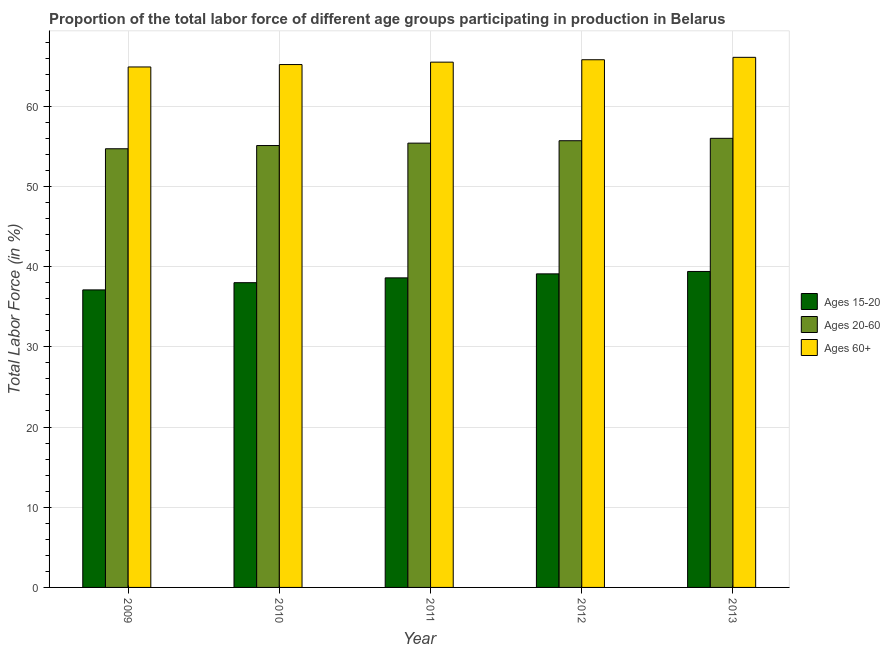How many groups of bars are there?
Offer a terse response. 5. Are the number of bars per tick equal to the number of legend labels?
Ensure brevity in your answer.  Yes. Are the number of bars on each tick of the X-axis equal?
Ensure brevity in your answer.  Yes. How many bars are there on the 4th tick from the left?
Provide a succinct answer. 3. How many bars are there on the 4th tick from the right?
Your answer should be compact. 3. In how many cases, is the number of bars for a given year not equal to the number of legend labels?
Make the answer very short. 0. What is the percentage of labor force above age 60 in 2010?
Ensure brevity in your answer.  65.2. Across all years, what is the maximum percentage of labor force within the age group 15-20?
Give a very brief answer. 39.4. Across all years, what is the minimum percentage of labor force within the age group 20-60?
Your answer should be compact. 54.7. In which year was the percentage of labor force within the age group 15-20 minimum?
Your answer should be very brief. 2009. What is the total percentage of labor force above age 60 in the graph?
Offer a terse response. 327.5. What is the difference between the percentage of labor force within the age group 15-20 in 2009 and that in 2013?
Your answer should be very brief. -2.3. What is the difference between the percentage of labor force within the age group 15-20 in 2011 and the percentage of labor force above age 60 in 2013?
Give a very brief answer. -0.8. What is the average percentage of labor force within the age group 20-60 per year?
Give a very brief answer. 55.38. In how many years, is the percentage of labor force above age 60 greater than 28 %?
Give a very brief answer. 5. What is the ratio of the percentage of labor force within the age group 15-20 in 2009 to that in 2010?
Give a very brief answer. 0.98. Is the difference between the percentage of labor force above age 60 in 2011 and 2012 greater than the difference between the percentage of labor force within the age group 20-60 in 2011 and 2012?
Give a very brief answer. No. What is the difference between the highest and the second highest percentage of labor force above age 60?
Your answer should be compact. 0.3. What is the difference between the highest and the lowest percentage of labor force above age 60?
Make the answer very short. 1.2. In how many years, is the percentage of labor force within the age group 20-60 greater than the average percentage of labor force within the age group 20-60 taken over all years?
Ensure brevity in your answer.  3. Is the sum of the percentage of labor force within the age group 15-20 in 2011 and 2013 greater than the maximum percentage of labor force within the age group 20-60 across all years?
Your response must be concise. Yes. What does the 3rd bar from the left in 2011 represents?
Give a very brief answer. Ages 60+. What does the 2nd bar from the right in 2010 represents?
Your answer should be very brief. Ages 20-60. How many bars are there?
Provide a short and direct response. 15. Are all the bars in the graph horizontal?
Offer a terse response. No. How are the legend labels stacked?
Offer a very short reply. Vertical. What is the title of the graph?
Your answer should be very brief. Proportion of the total labor force of different age groups participating in production in Belarus. What is the label or title of the X-axis?
Your answer should be very brief. Year. What is the label or title of the Y-axis?
Give a very brief answer. Total Labor Force (in %). What is the Total Labor Force (in %) in Ages 15-20 in 2009?
Offer a very short reply. 37.1. What is the Total Labor Force (in %) in Ages 20-60 in 2009?
Make the answer very short. 54.7. What is the Total Labor Force (in %) in Ages 60+ in 2009?
Your answer should be very brief. 64.9. What is the Total Labor Force (in %) in Ages 15-20 in 2010?
Ensure brevity in your answer.  38. What is the Total Labor Force (in %) of Ages 20-60 in 2010?
Your answer should be very brief. 55.1. What is the Total Labor Force (in %) in Ages 60+ in 2010?
Give a very brief answer. 65.2. What is the Total Labor Force (in %) of Ages 15-20 in 2011?
Your answer should be very brief. 38.6. What is the Total Labor Force (in %) of Ages 20-60 in 2011?
Your answer should be compact. 55.4. What is the Total Labor Force (in %) in Ages 60+ in 2011?
Offer a terse response. 65.5. What is the Total Labor Force (in %) in Ages 15-20 in 2012?
Offer a terse response. 39.1. What is the Total Labor Force (in %) in Ages 20-60 in 2012?
Provide a succinct answer. 55.7. What is the Total Labor Force (in %) in Ages 60+ in 2012?
Offer a terse response. 65.8. What is the Total Labor Force (in %) of Ages 15-20 in 2013?
Offer a terse response. 39.4. What is the Total Labor Force (in %) of Ages 20-60 in 2013?
Ensure brevity in your answer.  56. What is the Total Labor Force (in %) of Ages 60+ in 2013?
Offer a very short reply. 66.1. Across all years, what is the maximum Total Labor Force (in %) of Ages 15-20?
Make the answer very short. 39.4. Across all years, what is the maximum Total Labor Force (in %) of Ages 60+?
Provide a succinct answer. 66.1. Across all years, what is the minimum Total Labor Force (in %) of Ages 15-20?
Your answer should be compact. 37.1. Across all years, what is the minimum Total Labor Force (in %) in Ages 20-60?
Make the answer very short. 54.7. Across all years, what is the minimum Total Labor Force (in %) of Ages 60+?
Ensure brevity in your answer.  64.9. What is the total Total Labor Force (in %) of Ages 15-20 in the graph?
Keep it short and to the point. 192.2. What is the total Total Labor Force (in %) in Ages 20-60 in the graph?
Provide a succinct answer. 276.9. What is the total Total Labor Force (in %) in Ages 60+ in the graph?
Provide a succinct answer. 327.5. What is the difference between the Total Labor Force (in %) in Ages 15-20 in 2009 and that in 2010?
Provide a short and direct response. -0.9. What is the difference between the Total Labor Force (in %) in Ages 20-60 in 2009 and that in 2010?
Your response must be concise. -0.4. What is the difference between the Total Labor Force (in %) in Ages 60+ in 2009 and that in 2010?
Provide a short and direct response. -0.3. What is the difference between the Total Labor Force (in %) of Ages 15-20 in 2009 and that in 2011?
Give a very brief answer. -1.5. What is the difference between the Total Labor Force (in %) of Ages 20-60 in 2009 and that in 2011?
Ensure brevity in your answer.  -0.7. What is the difference between the Total Labor Force (in %) of Ages 20-60 in 2009 and that in 2012?
Give a very brief answer. -1. What is the difference between the Total Labor Force (in %) of Ages 20-60 in 2009 and that in 2013?
Provide a succinct answer. -1.3. What is the difference between the Total Labor Force (in %) in Ages 15-20 in 2010 and that in 2011?
Provide a succinct answer. -0.6. What is the difference between the Total Labor Force (in %) in Ages 60+ in 2010 and that in 2011?
Your response must be concise. -0.3. What is the difference between the Total Labor Force (in %) of Ages 15-20 in 2010 and that in 2012?
Offer a terse response. -1.1. What is the difference between the Total Labor Force (in %) in Ages 60+ in 2010 and that in 2012?
Offer a very short reply. -0.6. What is the difference between the Total Labor Force (in %) of Ages 60+ in 2010 and that in 2013?
Keep it short and to the point. -0.9. What is the difference between the Total Labor Force (in %) of Ages 20-60 in 2011 and that in 2012?
Your answer should be compact. -0.3. What is the difference between the Total Labor Force (in %) in Ages 60+ in 2011 and that in 2012?
Ensure brevity in your answer.  -0.3. What is the difference between the Total Labor Force (in %) of Ages 15-20 in 2011 and that in 2013?
Keep it short and to the point. -0.8. What is the difference between the Total Labor Force (in %) of Ages 15-20 in 2012 and that in 2013?
Ensure brevity in your answer.  -0.3. What is the difference between the Total Labor Force (in %) in Ages 20-60 in 2012 and that in 2013?
Your answer should be compact. -0.3. What is the difference between the Total Labor Force (in %) in Ages 60+ in 2012 and that in 2013?
Keep it short and to the point. -0.3. What is the difference between the Total Labor Force (in %) of Ages 15-20 in 2009 and the Total Labor Force (in %) of Ages 20-60 in 2010?
Provide a short and direct response. -18. What is the difference between the Total Labor Force (in %) in Ages 15-20 in 2009 and the Total Labor Force (in %) in Ages 60+ in 2010?
Keep it short and to the point. -28.1. What is the difference between the Total Labor Force (in %) of Ages 15-20 in 2009 and the Total Labor Force (in %) of Ages 20-60 in 2011?
Offer a very short reply. -18.3. What is the difference between the Total Labor Force (in %) in Ages 15-20 in 2009 and the Total Labor Force (in %) in Ages 60+ in 2011?
Provide a succinct answer. -28.4. What is the difference between the Total Labor Force (in %) in Ages 15-20 in 2009 and the Total Labor Force (in %) in Ages 20-60 in 2012?
Provide a succinct answer. -18.6. What is the difference between the Total Labor Force (in %) in Ages 15-20 in 2009 and the Total Labor Force (in %) in Ages 60+ in 2012?
Provide a short and direct response. -28.7. What is the difference between the Total Labor Force (in %) of Ages 15-20 in 2009 and the Total Labor Force (in %) of Ages 20-60 in 2013?
Provide a succinct answer. -18.9. What is the difference between the Total Labor Force (in %) of Ages 20-60 in 2009 and the Total Labor Force (in %) of Ages 60+ in 2013?
Your answer should be very brief. -11.4. What is the difference between the Total Labor Force (in %) of Ages 15-20 in 2010 and the Total Labor Force (in %) of Ages 20-60 in 2011?
Your answer should be very brief. -17.4. What is the difference between the Total Labor Force (in %) of Ages 15-20 in 2010 and the Total Labor Force (in %) of Ages 60+ in 2011?
Your response must be concise. -27.5. What is the difference between the Total Labor Force (in %) of Ages 20-60 in 2010 and the Total Labor Force (in %) of Ages 60+ in 2011?
Make the answer very short. -10.4. What is the difference between the Total Labor Force (in %) of Ages 15-20 in 2010 and the Total Labor Force (in %) of Ages 20-60 in 2012?
Ensure brevity in your answer.  -17.7. What is the difference between the Total Labor Force (in %) in Ages 15-20 in 2010 and the Total Labor Force (in %) in Ages 60+ in 2012?
Ensure brevity in your answer.  -27.8. What is the difference between the Total Labor Force (in %) of Ages 20-60 in 2010 and the Total Labor Force (in %) of Ages 60+ in 2012?
Give a very brief answer. -10.7. What is the difference between the Total Labor Force (in %) in Ages 15-20 in 2010 and the Total Labor Force (in %) in Ages 20-60 in 2013?
Offer a very short reply. -18. What is the difference between the Total Labor Force (in %) in Ages 15-20 in 2010 and the Total Labor Force (in %) in Ages 60+ in 2013?
Offer a very short reply. -28.1. What is the difference between the Total Labor Force (in %) in Ages 15-20 in 2011 and the Total Labor Force (in %) in Ages 20-60 in 2012?
Your answer should be very brief. -17.1. What is the difference between the Total Labor Force (in %) in Ages 15-20 in 2011 and the Total Labor Force (in %) in Ages 60+ in 2012?
Keep it short and to the point. -27.2. What is the difference between the Total Labor Force (in %) in Ages 15-20 in 2011 and the Total Labor Force (in %) in Ages 20-60 in 2013?
Give a very brief answer. -17.4. What is the difference between the Total Labor Force (in %) of Ages 15-20 in 2011 and the Total Labor Force (in %) of Ages 60+ in 2013?
Ensure brevity in your answer.  -27.5. What is the difference between the Total Labor Force (in %) of Ages 20-60 in 2011 and the Total Labor Force (in %) of Ages 60+ in 2013?
Offer a very short reply. -10.7. What is the difference between the Total Labor Force (in %) of Ages 15-20 in 2012 and the Total Labor Force (in %) of Ages 20-60 in 2013?
Provide a short and direct response. -16.9. What is the difference between the Total Labor Force (in %) of Ages 15-20 in 2012 and the Total Labor Force (in %) of Ages 60+ in 2013?
Ensure brevity in your answer.  -27. What is the difference between the Total Labor Force (in %) of Ages 20-60 in 2012 and the Total Labor Force (in %) of Ages 60+ in 2013?
Your response must be concise. -10.4. What is the average Total Labor Force (in %) of Ages 15-20 per year?
Your answer should be very brief. 38.44. What is the average Total Labor Force (in %) in Ages 20-60 per year?
Provide a succinct answer. 55.38. What is the average Total Labor Force (in %) of Ages 60+ per year?
Provide a succinct answer. 65.5. In the year 2009, what is the difference between the Total Labor Force (in %) of Ages 15-20 and Total Labor Force (in %) of Ages 20-60?
Provide a succinct answer. -17.6. In the year 2009, what is the difference between the Total Labor Force (in %) in Ages 15-20 and Total Labor Force (in %) in Ages 60+?
Provide a short and direct response. -27.8. In the year 2010, what is the difference between the Total Labor Force (in %) in Ages 15-20 and Total Labor Force (in %) in Ages 20-60?
Keep it short and to the point. -17.1. In the year 2010, what is the difference between the Total Labor Force (in %) of Ages 15-20 and Total Labor Force (in %) of Ages 60+?
Your answer should be very brief. -27.2. In the year 2010, what is the difference between the Total Labor Force (in %) of Ages 20-60 and Total Labor Force (in %) of Ages 60+?
Make the answer very short. -10.1. In the year 2011, what is the difference between the Total Labor Force (in %) in Ages 15-20 and Total Labor Force (in %) in Ages 20-60?
Your response must be concise. -16.8. In the year 2011, what is the difference between the Total Labor Force (in %) of Ages 15-20 and Total Labor Force (in %) of Ages 60+?
Your response must be concise. -26.9. In the year 2012, what is the difference between the Total Labor Force (in %) in Ages 15-20 and Total Labor Force (in %) in Ages 20-60?
Keep it short and to the point. -16.6. In the year 2012, what is the difference between the Total Labor Force (in %) in Ages 15-20 and Total Labor Force (in %) in Ages 60+?
Keep it short and to the point. -26.7. In the year 2012, what is the difference between the Total Labor Force (in %) in Ages 20-60 and Total Labor Force (in %) in Ages 60+?
Offer a terse response. -10.1. In the year 2013, what is the difference between the Total Labor Force (in %) in Ages 15-20 and Total Labor Force (in %) in Ages 20-60?
Your answer should be very brief. -16.6. In the year 2013, what is the difference between the Total Labor Force (in %) of Ages 15-20 and Total Labor Force (in %) of Ages 60+?
Provide a short and direct response. -26.7. In the year 2013, what is the difference between the Total Labor Force (in %) in Ages 20-60 and Total Labor Force (in %) in Ages 60+?
Offer a very short reply. -10.1. What is the ratio of the Total Labor Force (in %) of Ages 15-20 in 2009 to that in 2010?
Offer a very short reply. 0.98. What is the ratio of the Total Labor Force (in %) in Ages 20-60 in 2009 to that in 2010?
Your response must be concise. 0.99. What is the ratio of the Total Labor Force (in %) of Ages 15-20 in 2009 to that in 2011?
Your answer should be very brief. 0.96. What is the ratio of the Total Labor Force (in %) of Ages 20-60 in 2009 to that in 2011?
Provide a succinct answer. 0.99. What is the ratio of the Total Labor Force (in %) in Ages 60+ in 2009 to that in 2011?
Provide a succinct answer. 0.99. What is the ratio of the Total Labor Force (in %) in Ages 15-20 in 2009 to that in 2012?
Make the answer very short. 0.95. What is the ratio of the Total Labor Force (in %) in Ages 60+ in 2009 to that in 2012?
Ensure brevity in your answer.  0.99. What is the ratio of the Total Labor Force (in %) in Ages 15-20 in 2009 to that in 2013?
Offer a terse response. 0.94. What is the ratio of the Total Labor Force (in %) of Ages 20-60 in 2009 to that in 2013?
Offer a very short reply. 0.98. What is the ratio of the Total Labor Force (in %) of Ages 60+ in 2009 to that in 2013?
Keep it short and to the point. 0.98. What is the ratio of the Total Labor Force (in %) of Ages 15-20 in 2010 to that in 2011?
Offer a terse response. 0.98. What is the ratio of the Total Labor Force (in %) in Ages 20-60 in 2010 to that in 2011?
Provide a short and direct response. 0.99. What is the ratio of the Total Labor Force (in %) of Ages 60+ in 2010 to that in 2011?
Keep it short and to the point. 1. What is the ratio of the Total Labor Force (in %) of Ages 15-20 in 2010 to that in 2012?
Keep it short and to the point. 0.97. What is the ratio of the Total Labor Force (in %) in Ages 60+ in 2010 to that in 2012?
Offer a terse response. 0.99. What is the ratio of the Total Labor Force (in %) in Ages 15-20 in 2010 to that in 2013?
Offer a terse response. 0.96. What is the ratio of the Total Labor Force (in %) in Ages 20-60 in 2010 to that in 2013?
Offer a terse response. 0.98. What is the ratio of the Total Labor Force (in %) of Ages 60+ in 2010 to that in 2013?
Give a very brief answer. 0.99. What is the ratio of the Total Labor Force (in %) of Ages 15-20 in 2011 to that in 2012?
Your response must be concise. 0.99. What is the ratio of the Total Labor Force (in %) in Ages 15-20 in 2011 to that in 2013?
Your response must be concise. 0.98. What is the ratio of the Total Labor Force (in %) of Ages 20-60 in 2011 to that in 2013?
Give a very brief answer. 0.99. What is the ratio of the Total Labor Force (in %) of Ages 60+ in 2011 to that in 2013?
Make the answer very short. 0.99. What is the ratio of the Total Labor Force (in %) in Ages 15-20 in 2012 to that in 2013?
Your answer should be compact. 0.99. What is the difference between the highest and the second highest Total Labor Force (in %) in Ages 20-60?
Your response must be concise. 0.3. What is the difference between the highest and the second highest Total Labor Force (in %) in Ages 60+?
Your response must be concise. 0.3. What is the difference between the highest and the lowest Total Labor Force (in %) of Ages 15-20?
Your answer should be very brief. 2.3. 